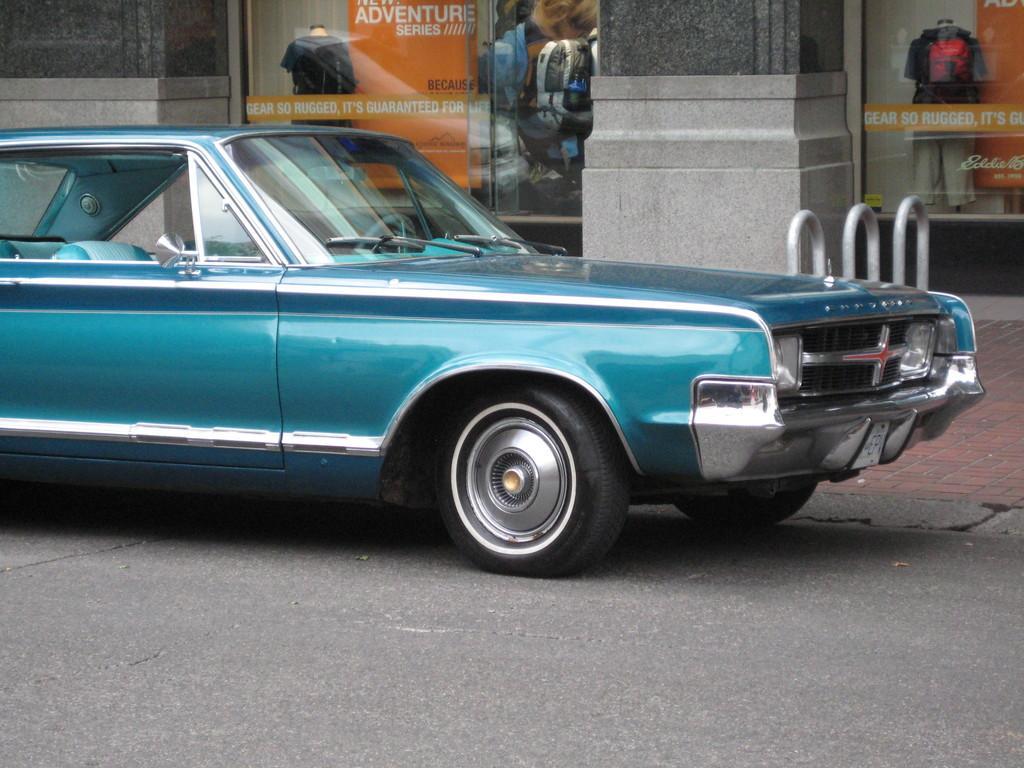In one or two sentences, can you explain what this image depicts? In this image we can see a motor vehicle on the road, mannequin with dress and an advertisement board. 